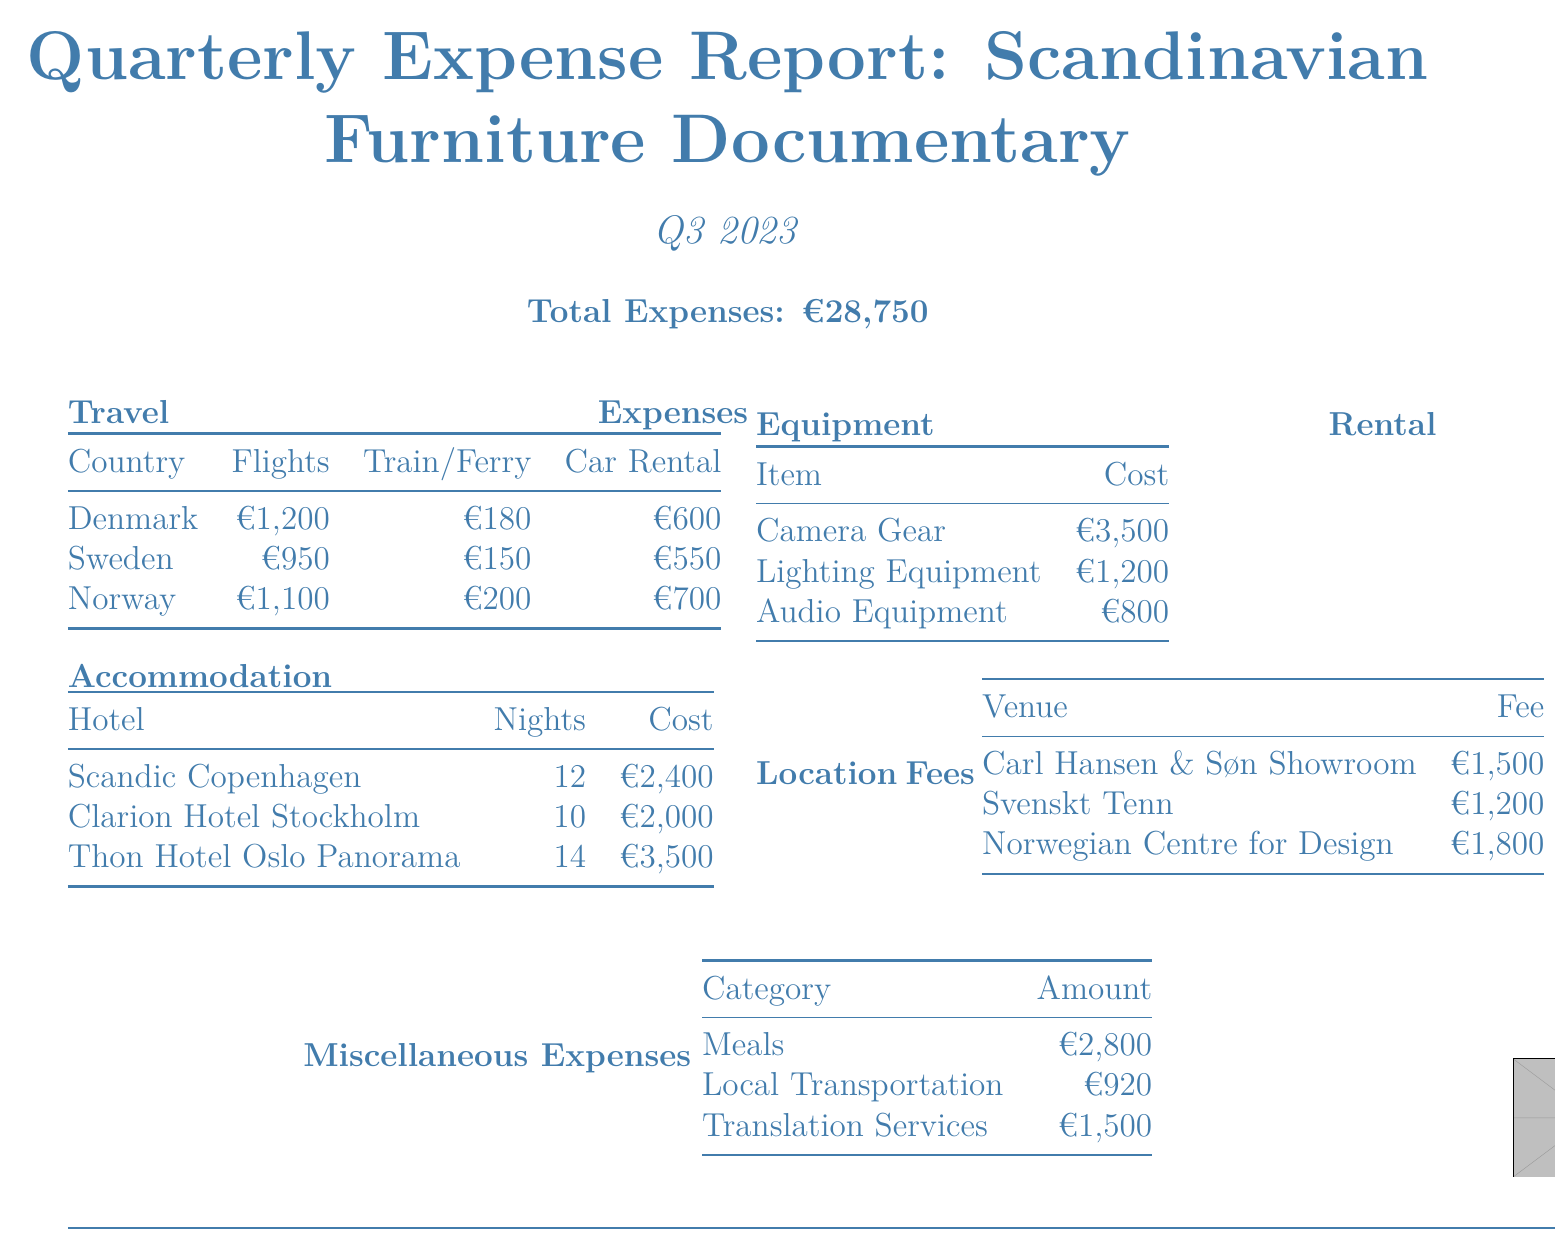What is the total expense for the quarter? The total expense is explicitly stated in the document.
Answer: €28,750 What accommodations were used in Denmark? The document lists "Scandic Copenhagen" as the hotel for Denmark.
Answer: Scandic Copenhagen How many nights were stayed in Sweden? The number of nights for Sweden's accommodation is provided in the report.
Answer: 10 What is the cost of the lighting equipment rental? The cost for lighting equipment is mentioned under equipment rental expenses.
Answer: €1,200 Which venue in Norway had the highest location fee? The document provides location fees for different venues, allowing comparison.
Answer: Norwegian Centre for Design and Architecture What were the total travel expenses for Denmark? The travel expenses for Denmark include flights, train tickets, and car rental, which can be summed up from the respective entries.
Answer: €1,980 How much was spent on meals overall? The document specifies the total cost allocated to meals as a miscellaneous expense.
Answer: €2,800 Which country had the highest car rental expense? Comparing the car rental expenses listed for each country allows for easy identification of the highest amount.
Answer: Norway What is the total amount spent on accommodation in Norway? The cost of accommodation for Norway is specifically mentioned and can be referenced directly.
Answer: €3,500 